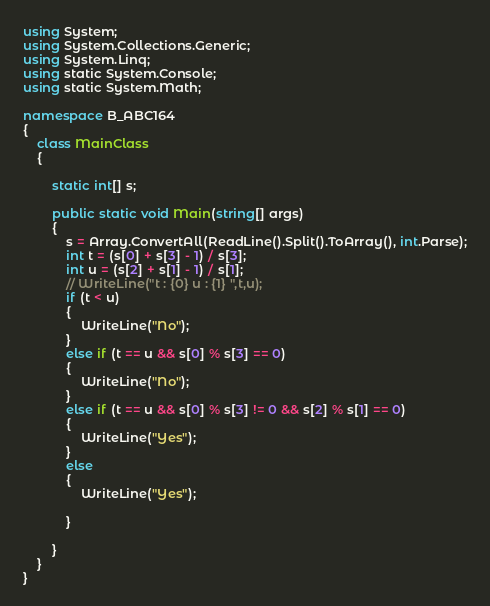Convert code to text. <code><loc_0><loc_0><loc_500><loc_500><_C#_>using System;
using System.Collections.Generic;
using System.Linq;
using static System.Console;
using static System.Math;

namespace B_ABC164
{
    class MainClass
    {

        static int[] s;

        public static void Main(string[] args)
        {
            s = Array.ConvertAll(ReadLine().Split().ToArray(), int.Parse);
            int t = (s[0] + s[3] - 1) / s[3];
            int u = (s[2] + s[1] - 1) / s[1];
            // WriteLine("t : {0} u : {1} ",t,u);
            if (t < u)
            {
                WriteLine("No");
            }
            else if (t == u && s[0] % s[3] == 0)
            {
                WriteLine("No");
            }
            else if (t == u && s[0] % s[3] != 0 && s[2] % s[1] == 0)
            {
                WriteLine("Yes");
            }
            else
            {
                WriteLine("Yes");

            }

        }
    }
}
</code> 